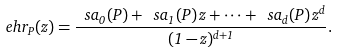<formula> <loc_0><loc_0><loc_500><loc_500>\ e h r _ { P } ( z ) = \frac { \ s a _ { 0 } ( P ) + \ s a _ { 1 } ( P ) \, z + \cdots + \ s a _ { d } ( P ) \, z ^ { d } } { ( 1 - z ) ^ { d + 1 } } .</formula> 